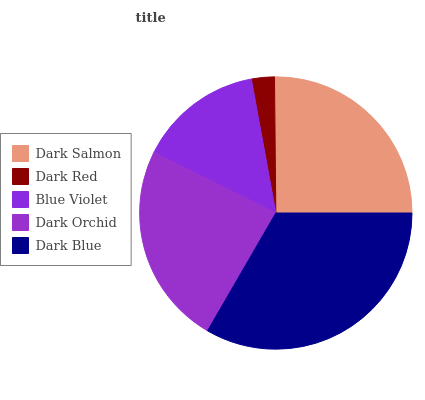Is Dark Red the minimum?
Answer yes or no. Yes. Is Dark Blue the maximum?
Answer yes or no. Yes. Is Blue Violet the minimum?
Answer yes or no. No. Is Blue Violet the maximum?
Answer yes or no. No. Is Blue Violet greater than Dark Red?
Answer yes or no. Yes. Is Dark Red less than Blue Violet?
Answer yes or no. Yes. Is Dark Red greater than Blue Violet?
Answer yes or no. No. Is Blue Violet less than Dark Red?
Answer yes or no. No. Is Dark Orchid the high median?
Answer yes or no. Yes. Is Dark Orchid the low median?
Answer yes or no. Yes. Is Dark Red the high median?
Answer yes or no. No. Is Blue Violet the low median?
Answer yes or no. No. 